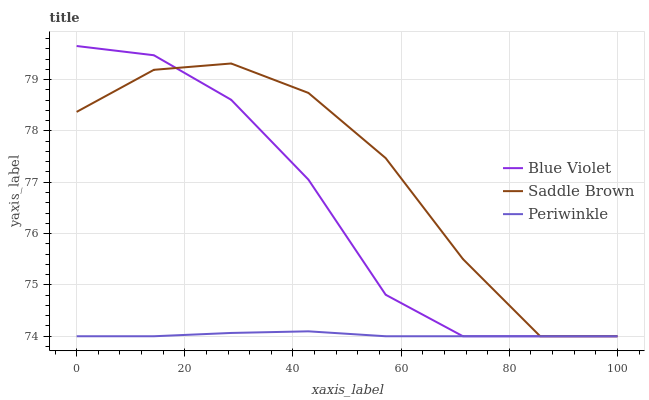Does Periwinkle have the minimum area under the curve?
Answer yes or no. Yes. Does Saddle Brown have the maximum area under the curve?
Answer yes or no. Yes. Does Blue Violet have the minimum area under the curve?
Answer yes or no. No. Does Blue Violet have the maximum area under the curve?
Answer yes or no. No. Is Periwinkle the smoothest?
Answer yes or no. Yes. Is Saddle Brown the roughest?
Answer yes or no. Yes. Is Blue Violet the smoothest?
Answer yes or no. No. Is Blue Violet the roughest?
Answer yes or no. No. Does Periwinkle have the lowest value?
Answer yes or no. Yes. Does Blue Violet have the highest value?
Answer yes or no. Yes. Does Saddle Brown have the highest value?
Answer yes or no. No. Does Blue Violet intersect Periwinkle?
Answer yes or no. Yes. Is Blue Violet less than Periwinkle?
Answer yes or no. No. Is Blue Violet greater than Periwinkle?
Answer yes or no. No. 